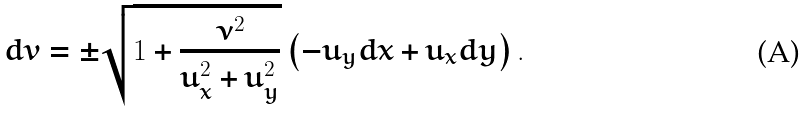Convert formula to latex. <formula><loc_0><loc_0><loc_500><loc_500>d v = \pm \sqrt { 1 + \frac { \nu ^ { 2 } } { u _ { x } ^ { 2 } + u _ { y } ^ { 2 } } } \left ( - u _ { y } d x + u _ { x } d y \right ) .</formula> 